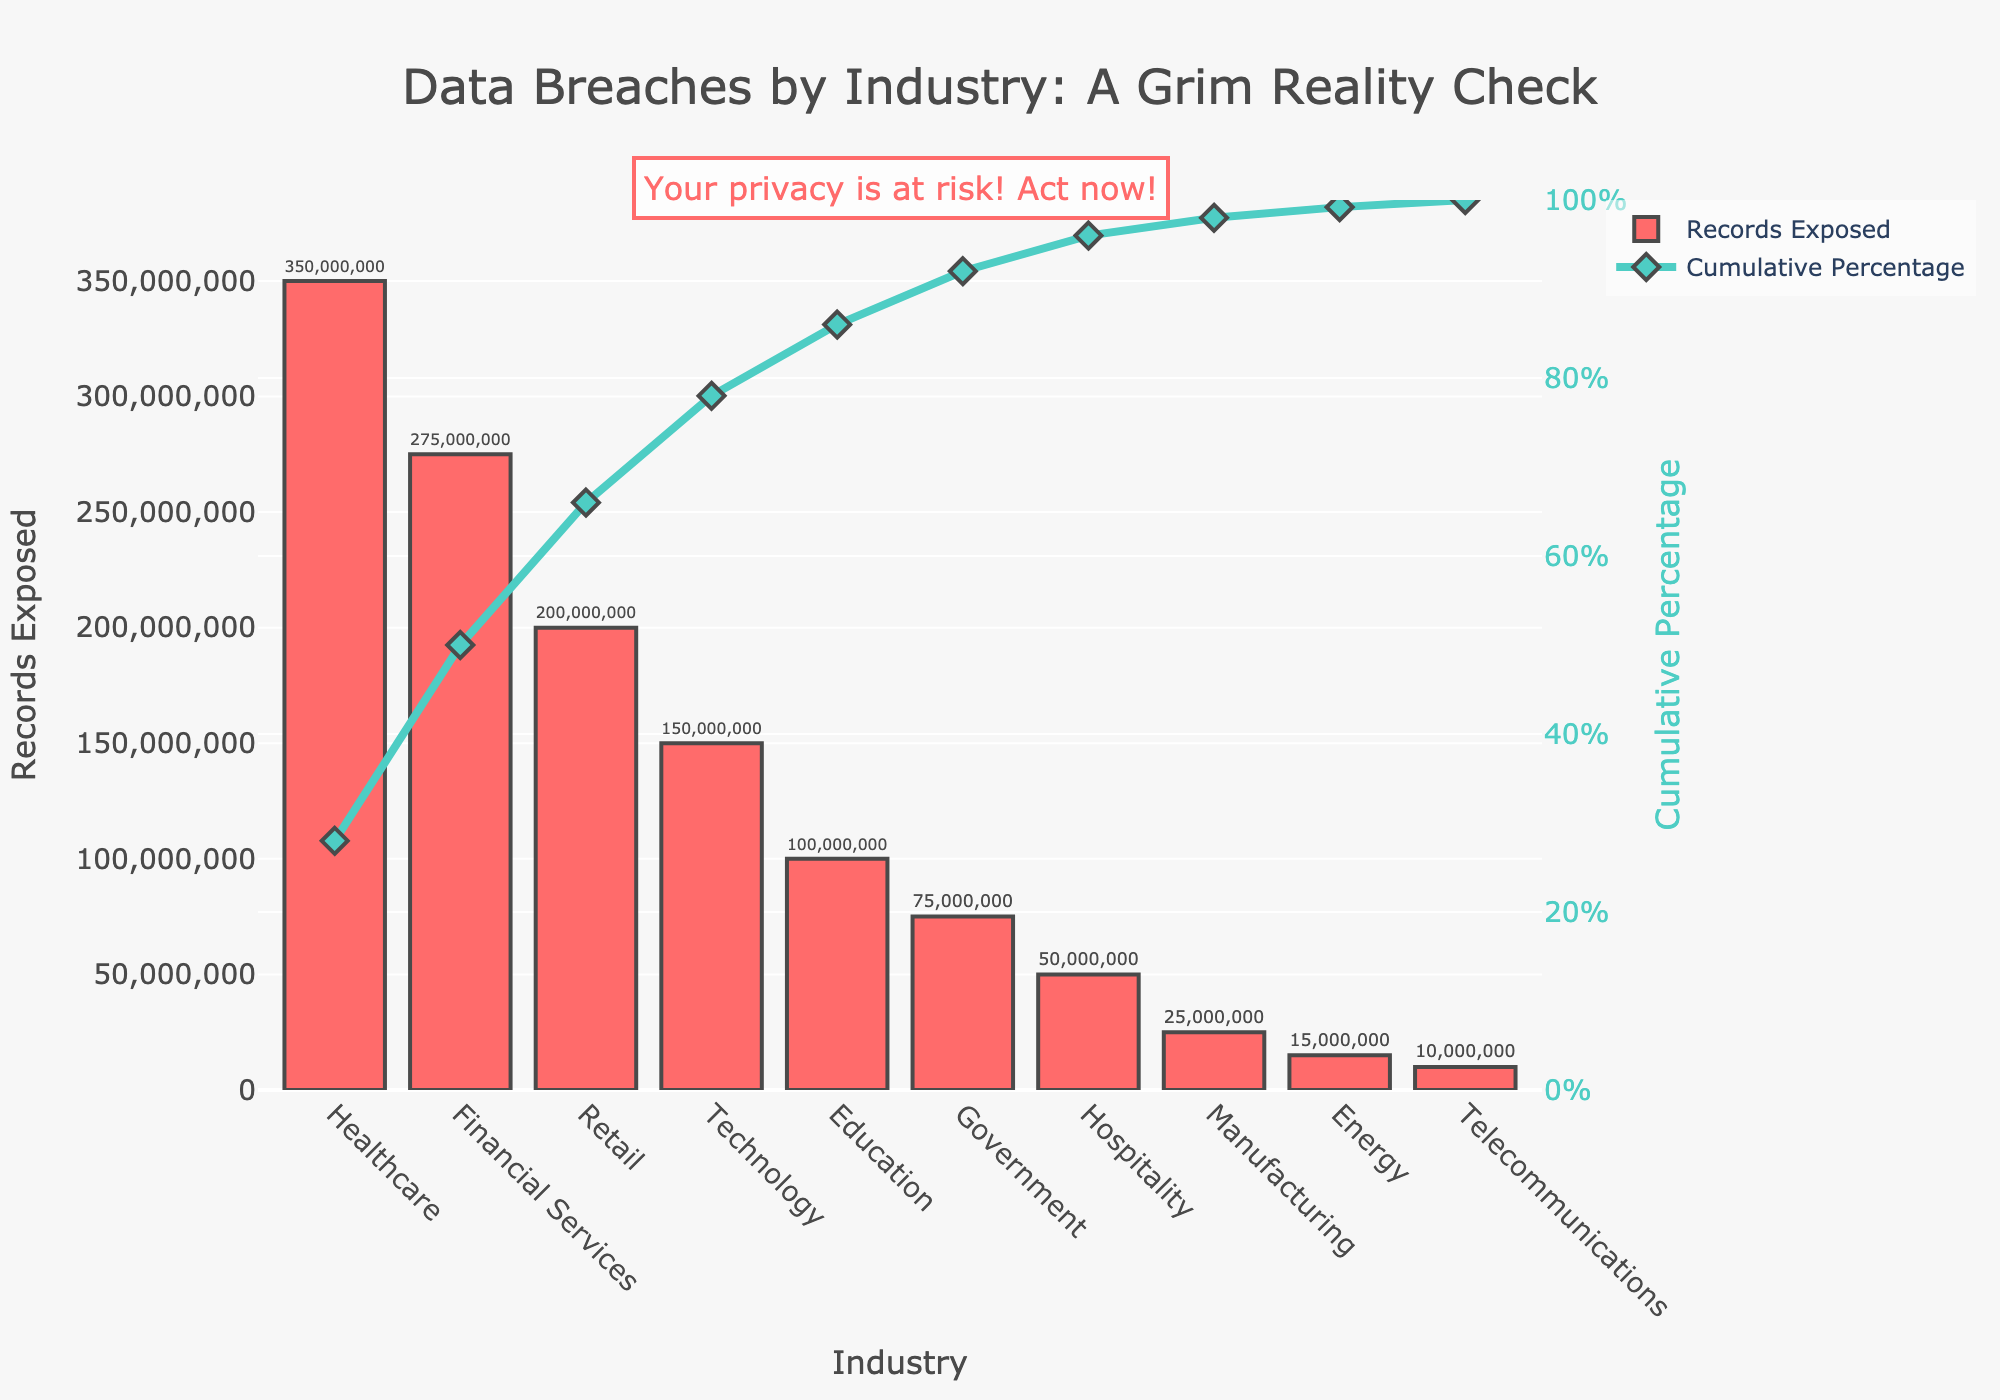Which industry has the highest number of records exposed? The highest bar represents the industry with the most records exposed, which is Healthcare.
Answer: Healthcare What is the cumulative percentage of records exposed by the top three industries? Add the cumulative percentages of Healthcare, Financial Services, and Retail. The values are around 34.1%, 60.8%, and 78.6% respectively, summing up to around 173.5%.
Answer: 173.5% How many records have been exposed in the Education sector? Locate the bar labeled "Education" and read the value at the top of the bar. The value is 100,000,000.
Answer: 100,000,000 Which industry is responsible for the smallest proportion of the cumulative percentage? The industry with the lowest cumulative percentage value is Telecommunications, at the very end, around 97.8%.
Answer: Telecommunications What percentage of total records are exposed by the Financial Services sector? The cumulative percentage of Financial Services is around 60.8%, then subtract the cumulative percentage of Healthcare which is around 34.1%. The result is around 26.7%.
Answer: 26.7% Compare the number of records exposed by the Retail sector to the Technology sector. Which one is greater and by how much? Find the value of the Retail sector (200,000,000) and the Technology sector (150,000,000), then subtract to find the difference. The Retail sector is greater by 50,000,000.
Answer: Retail, by 50,000,000 Where does the Government sector sit in terms of cumulative percentage? Look at the point where the line graph for cumulative percentage intersects with the Government bar. It is around 89.6%.
Answer: 89.6% How many industries are included in the Pareto chart? Count the number of bars shown in the figure. There are 10 industries.
Answer: 10 